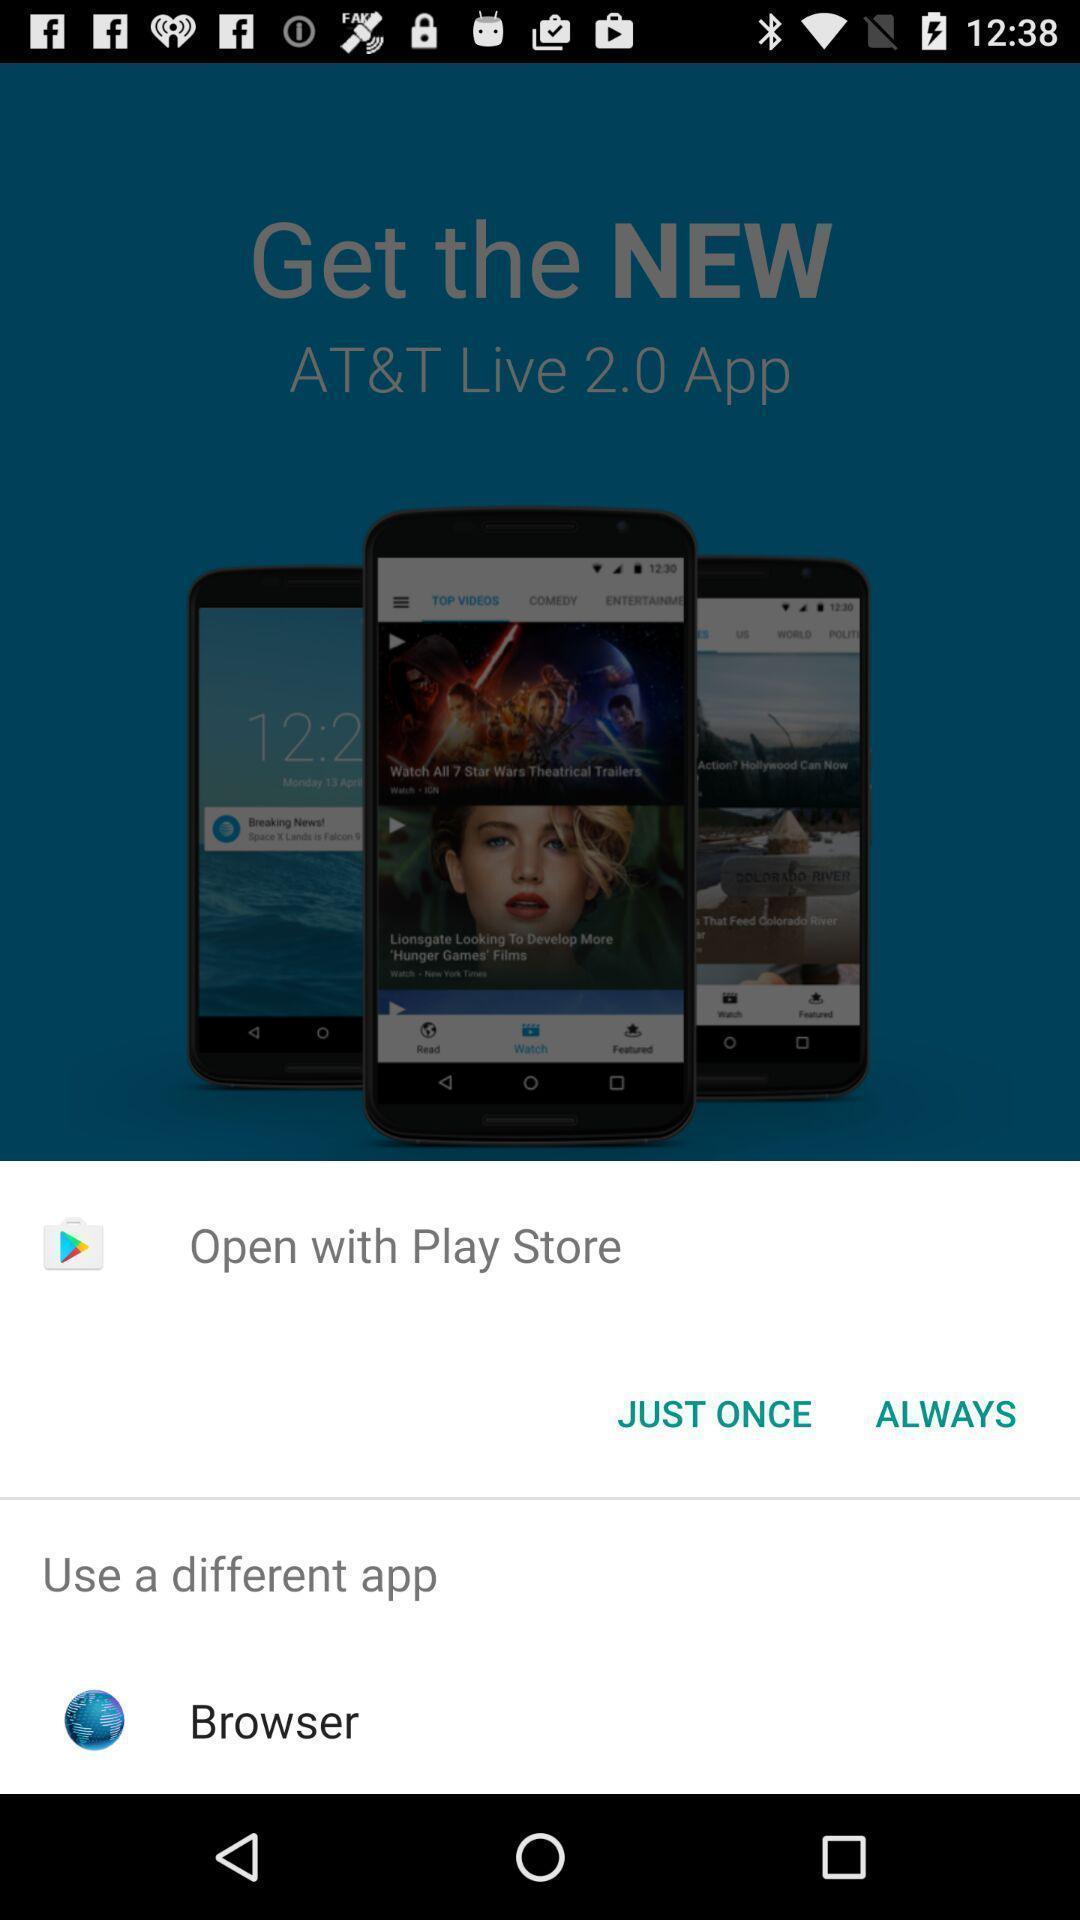Describe this image in words. Pop-up showing various options to open with. 